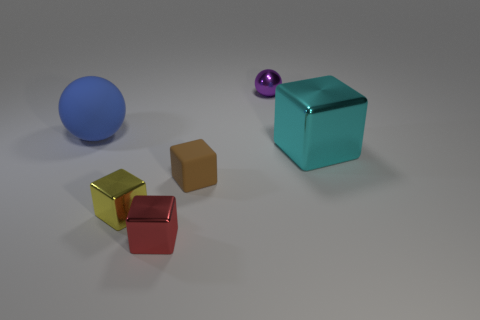What materials do the objects in the image appear to be made of? The objects in the image appear to be made of different materials; the large blue sphere looks like it's matte and possibly made of plastic or rubber, the small purple sphere seems to have a metallic sheen, the big cyan cube and the tiny red cube might be made of glass or a highly reflective plastic due to their shiny surfaces, and the gold and the brown cubes could be metallic or plastic with a matte finish. 